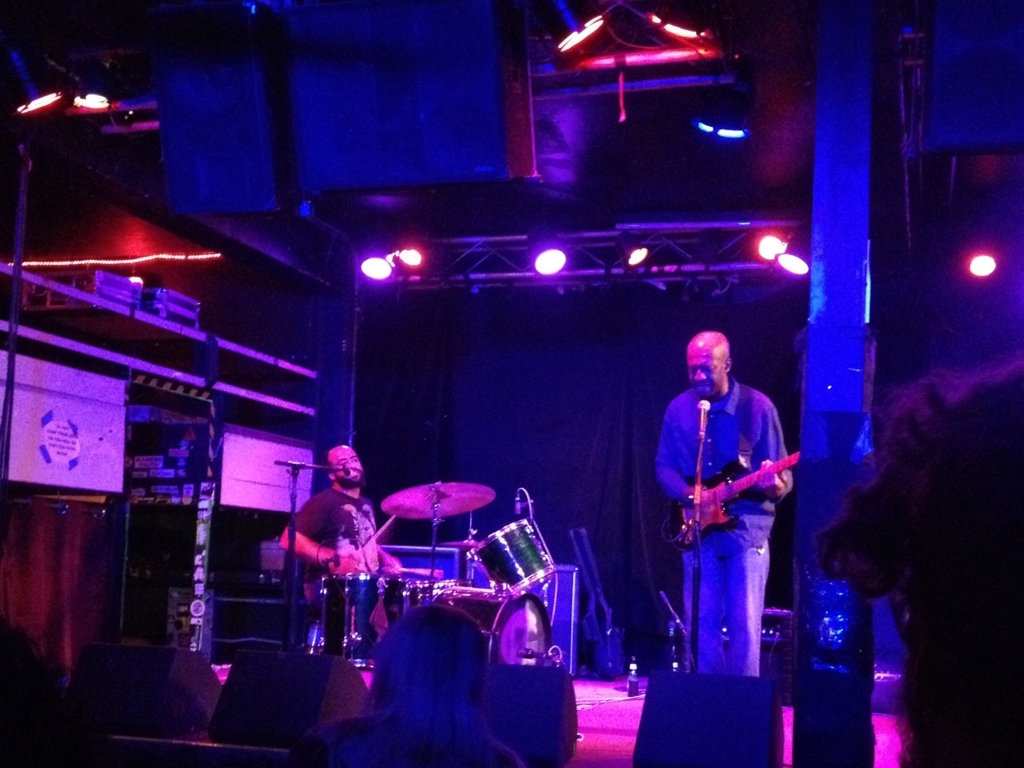Considering the audience's perspective shown in the image, how does this vantage point contribute to their experience? The viewpoint of the audience in this image appears to be quite close to the performers, which typically allows for a more personal and engaging experience. Being close to the stage can create a sense of connection with the musicians, as the subtleties of their expressions and movements are more visible. This proximity can enhance the feeling of being part of the event, rather than just an observer. 